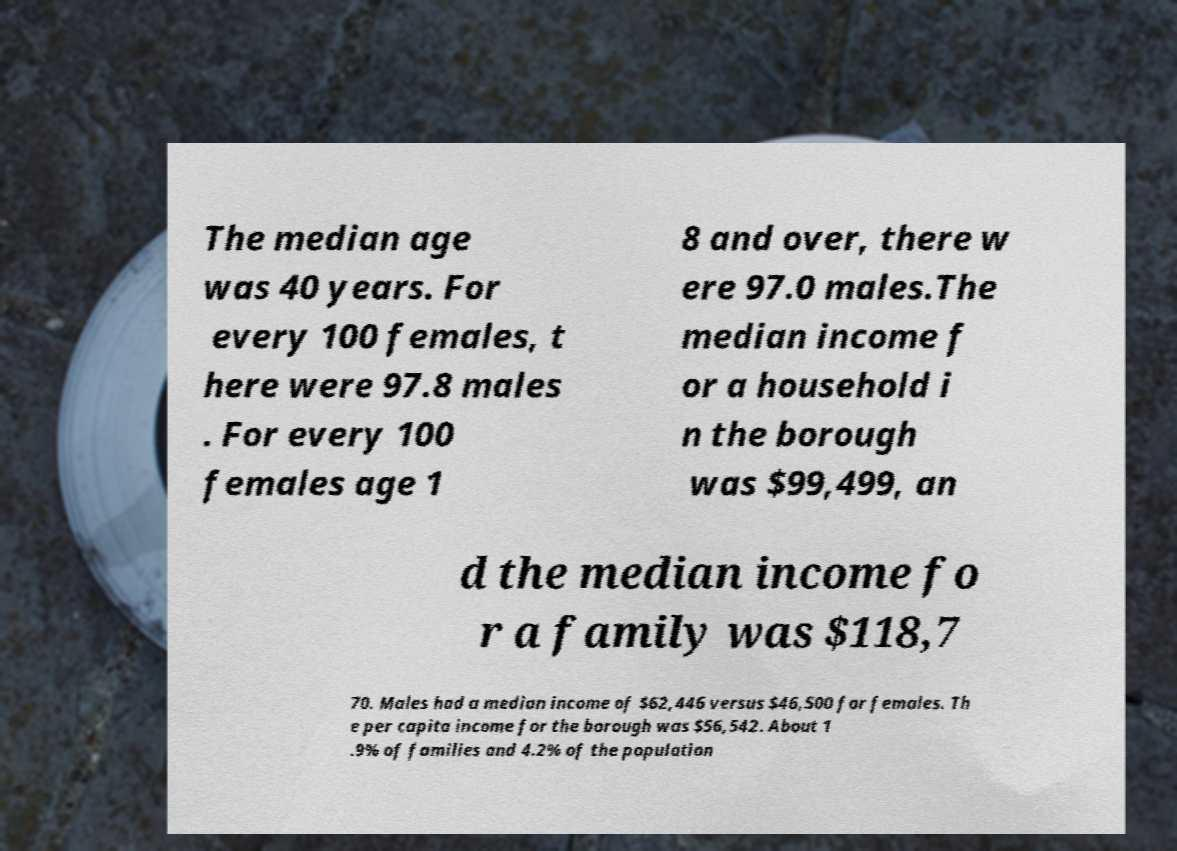Please read and relay the text visible in this image. What does it say? The median age was 40 years. For every 100 females, t here were 97.8 males . For every 100 females age 1 8 and over, there w ere 97.0 males.The median income f or a household i n the borough was $99,499, an d the median income fo r a family was $118,7 70. Males had a median income of $62,446 versus $46,500 for females. Th e per capita income for the borough was $56,542. About 1 .9% of families and 4.2% of the population 